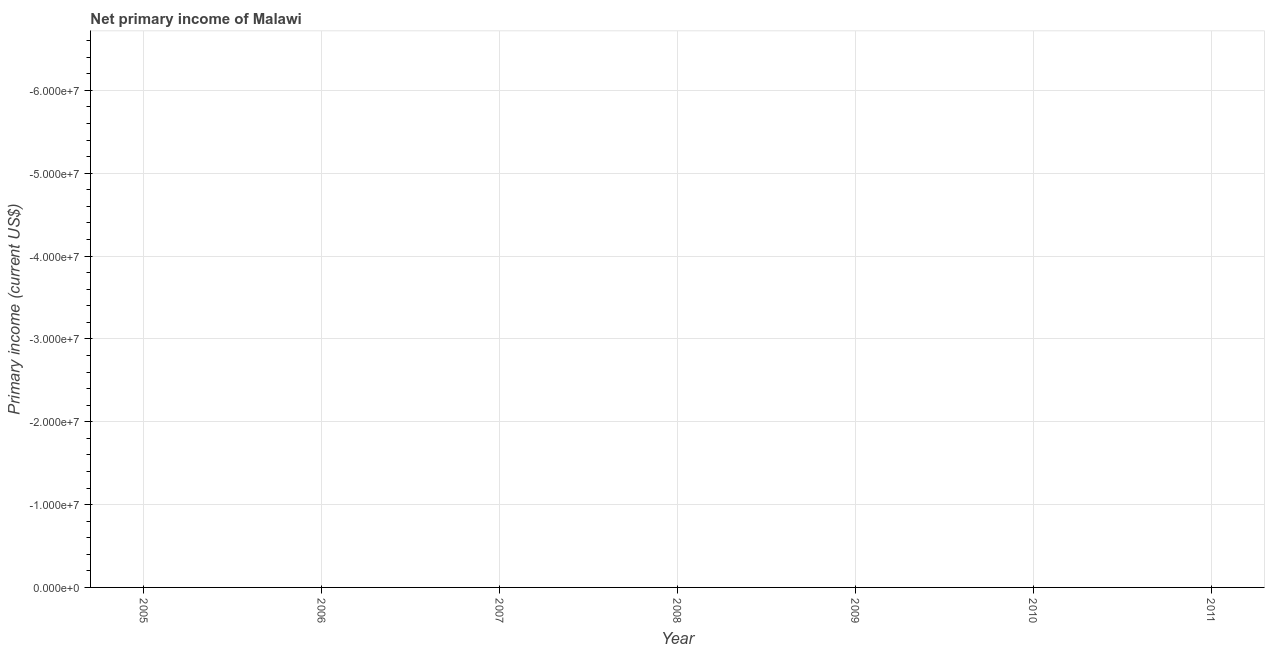What is the amount of primary income in 2007?
Give a very brief answer. 0. Across all years, what is the minimum amount of primary income?
Ensure brevity in your answer.  0. What is the average amount of primary income per year?
Your answer should be very brief. 0. How many lines are there?
Provide a succinct answer. 0. How many years are there in the graph?
Offer a very short reply. 7. What is the difference between two consecutive major ticks on the Y-axis?
Your answer should be compact. 1.00e+07. Are the values on the major ticks of Y-axis written in scientific E-notation?
Give a very brief answer. Yes. Does the graph contain any zero values?
Give a very brief answer. Yes. Does the graph contain grids?
Your response must be concise. Yes. What is the title of the graph?
Keep it short and to the point. Net primary income of Malawi. What is the label or title of the X-axis?
Your answer should be very brief. Year. What is the label or title of the Y-axis?
Your answer should be compact. Primary income (current US$). What is the Primary income (current US$) in 2005?
Keep it short and to the point. 0. What is the Primary income (current US$) of 2006?
Keep it short and to the point. 0. What is the Primary income (current US$) in 2009?
Make the answer very short. 0. What is the Primary income (current US$) of 2011?
Offer a terse response. 0. 